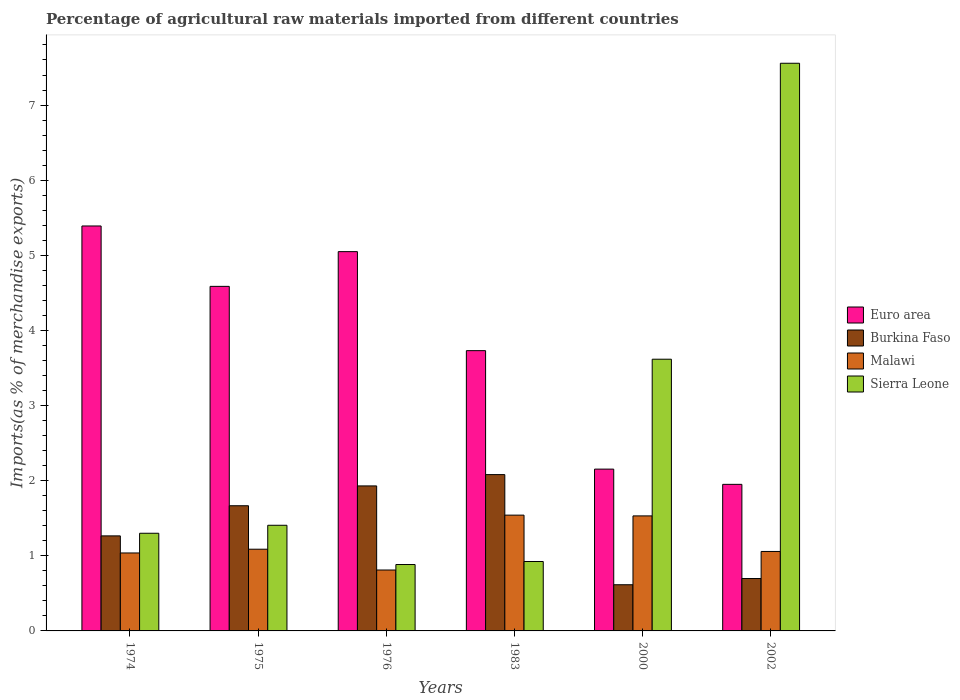Are the number of bars on each tick of the X-axis equal?
Provide a succinct answer. Yes. How many bars are there on the 4th tick from the right?
Provide a succinct answer. 4. What is the percentage of imports to different countries in Burkina Faso in 1983?
Ensure brevity in your answer.  2.08. Across all years, what is the maximum percentage of imports to different countries in Euro area?
Offer a terse response. 5.39. Across all years, what is the minimum percentage of imports to different countries in Burkina Faso?
Your response must be concise. 0.61. In which year was the percentage of imports to different countries in Sierra Leone maximum?
Make the answer very short. 2002. In which year was the percentage of imports to different countries in Euro area minimum?
Make the answer very short. 2002. What is the total percentage of imports to different countries in Sierra Leone in the graph?
Your answer should be compact. 15.69. What is the difference between the percentage of imports to different countries in Sierra Leone in 1974 and that in 2002?
Ensure brevity in your answer.  -6.26. What is the difference between the percentage of imports to different countries in Malawi in 1975 and the percentage of imports to different countries in Burkina Faso in 1974?
Ensure brevity in your answer.  -0.18. What is the average percentage of imports to different countries in Burkina Faso per year?
Provide a succinct answer. 1.38. In the year 1983, what is the difference between the percentage of imports to different countries in Burkina Faso and percentage of imports to different countries in Euro area?
Provide a short and direct response. -1.65. In how many years, is the percentage of imports to different countries in Sierra Leone greater than 6.4 %?
Provide a short and direct response. 1. What is the ratio of the percentage of imports to different countries in Malawi in 1974 to that in 1975?
Provide a succinct answer. 0.95. What is the difference between the highest and the second highest percentage of imports to different countries in Euro area?
Your answer should be compact. 0.34. What is the difference between the highest and the lowest percentage of imports to different countries in Sierra Leone?
Provide a short and direct response. 6.67. Is the sum of the percentage of imports to different countries in Burkina Faso in 1974 and 1976 greater than the maximum percentage of imports to different countries in Malawi across all years?
Your response must be concise. Yes. Is it the case that in every year, the sum of the percentage of imports to different countries in Malawi and percentage of imports to different countries in Burkina Faso is greater than the sum of percentage of imports to different countries in Sierra Leone and percentage of imports to different countries in Euro area?
Your answer should be very brief. No. What does the 4th bar from the left in 1976 represents?
Offer a very short reply. Sierra Leone. What does the 1st bar from the right in 1974 represents?
Your response must be concise. Sierra Leone. Is it the case that in every year, the sum of the percentage of imports to different countries in Sierra Leone and percentage of imports to different countries in Euro area is greater than the percentage of imports to different countries in Burkina Faso?
Keep it short and to the point. Yes. Are the values on the major ticks of Y-axis written in scientific E-notation?
Offer a very short reply. No. Does the graph contain any zero values?
Your response must be concise. No. Does the graph contain grids?
Your response must be concise. No. How many legend labels are there?
Offer a terse response. 4. What is the title of the graph?
Your answer should be very brief. Percentage of agricultural raw materials imported from different countries. What is the label or title of the X-axis?
Your answer should be compact. Years. What is the label or title of the Y-axis?
Ensure brevity in your answer.  Imports(as % of merchandise exports). What is the Imports(as % of merchandise exports) in Euro area in 1974?
Provide a short and direct response. 5.39. What is the Imports(as % of merchandise exports) of Burkina Faso in 1974?
Offer a terse response. 1.27. What is the Imports(as % of merchandise exports) in Malawi in 1974?
Provide a short and direct response. 1.04. What is the Imports(as % of merchandise exports) of Sierra Leone in 1974?
Keep it short and to the point. 1.3. What is the Imports(as % of merchandise exports) in Euro area in 1975?
Your response must be concise. 4.59. What is the Imports(as % of merchandise exports) in Burkina Faso in 1975?
Your answer should be compact. 1.67. What is the Imports(as % of merchandise exports) of Malawi in 1975?
Your answer should be compact. 1.09. What is the Imports(as % of merchandise exports) in Sierra Leone in 1975?
Give a very brief answer. 1.41. What is the Imports(as % of merchandise exports) of Euro area in 1976?
Ensure brevity in your answer.  5.05. What is the Imports(as % of merchandise exports) in Burkina Faso in 1976?
Provide a short and direct response. 1.93. What is the Imports(as % of merchandise exports) of Malawi in 1976?
Offer a terse response. 0.81. What is the Imports(as % of merchandise exports) in Sierra Leone in 1976?
Ensure brevity in your answer.  0.88. What is the Imports(as % of merchandise exports) of Euro area in 1983?
Your answer should be very brief. 3.73. What is the Imports(as % of merchandise exports) of Burkina Faso in 1983?
Your response must be concise. 2.08. What is the Imports(as % of merchandise exports) of Malawi in 1983?
Your answer should be very brief. 1.54. What is the Imports(as % of merchandise exports) of Sierra Leone in 1983?
Keep it short and to the point. 0.92. What is the Imports(as % of merchandise exports) in Euro area in 2000?
Keep it short and to the point. 2.15. What is the Imports(as % of merchandise exports) in Burkina Faso in 2000?
Ensure brevity in your answer.  0.61. What is the Imports(as % of merchandise exports) in Malawi in 2000?
Your answer should be very brief. 1.53. What is the Imports(as % of merchandise exports) of Sierra Leone in 2000?
Provide a succinct answer. 3.62. What is the Imports(as % of merchandise exports) in Euro area in 2002?
Provide a succinct answer. 1.95. What is the Imports(as % of merchandise exports) in Burkina Faso in 2002?
Provide a short and direct response. 0.7. What is the Imports(as % of merchandise exports) of Malawi in 2002?
Your answer should be very brief. 1.06. What is the Imports(as % of merchandise exports) of Sierra Leone in 2002?
Provide a short and direct response. 7.56. Across all years, what is the maximum Imports(as % of merchandise exports) of Euro area?
Ensure brevity in your answer.  5.39. Across all years, what is the maximum Imports(as % of merchandise exports) of Burkina Faso?
Your answer should be compact. 2.08. Across all years, what is the maximum Imports(as % of merchandise exports) in Malawi?
Provide a short and direct response. 1.54. Across all years, what is the maximum Imports(as % of merchandise exports) in Sierra Leone?
Offer a very short reply. 7.56. Across all years, what is the minimum Imports(as % of merchandise exports) in Euro area?
Keep it short and to the point. 1.95. Across all years, what is the minimum Imports(as % of merchandise exports) of Burkina Faso?
Offer a very short reply. 0.61. Across all years, what is the minimum Imports(as % of merchandise exports) of Malawi?
Offer a terse response. 0.81. Across all years, what is the minimum Imports(as % of merchandise exports) in Sierra Leone?
Your answer should be very brief. 0.88. What is the total Imports(as % of merchandise exports) in Euro area in the graph?
Your answer should be compact. 22.86. What is the total Imports(as % of merchandise exports) in Burkina Faso in the graph?
Your answer should be very brief. 8.25. What is the total Imports(as % of merchandise exports) in Malawi in the graph?
Offer a terse response. 7.07. What is the total Imports(as % of merchandise exports) of Sierra Leone in the graph?
Provide a short and direct response. 15.69. What is the difference between the Imports(as % of merchandise exports) in Euro area in 1974 and that in 1975?
Offer a terse response. 0.8. What is the difference between the Imports(as % of merchandise exports) in Burkina Faso in 1974 and that in 1975?
Provide a succinct answer. -0.4. What is the difference between the Imports(as % of merchandise exports) in Malawi in 1974 and that in 1975?
Keep it short and to the point. -0.05. What is the difference between the Imports(as % of merchandise exports) in Sierra Leone in 1974 and that in 1975?
Give a very brief answer. -0.11. What is the difference between the Imports(as % of merchandise exports) in Euro area in 1974 and that in 1976?
Make the answer very short. 0.34. What is the difference between the Imports(as % of merchandise exports) of Burkina Faso in 1974 and that in 1976?
Offer a terse response. -0.67. What is the difference between the Imports(as % of merchandise exports) in Malawi in 1974 and that in 1976?
Your answer should be very brief. 0.23. What is the difference between the Imports(as % of merchandise exports) of Sierra Leone in 1974 and that in 1976?
Your answer should be compact. 0.42. What is the difference between the Imports(as % of merchandise exports) in Euro area in 1974 and that in 1983?
Offer a very short reply. 1.66. What is the difference between the Imports(as % of merchandise exports) of Burkina Faso in 1974 and that in 1983?
Your answer should be compact. -0.82. What is the difference between the Imports(as % of merchandise exports) of Malawi in 1974 and that in 1983?
Give a very brief answer. -0.5. What is the difference between the Imports(as % of merchandise exports) of Sierra Leone in 1974 and that in 1983?
Keep it short and to the point. 0.38. What is the difference between the Imports(as % of merchandise exports) of Euro area in 1974 and that in 2000?
Ensure brevity in your answer.  3.24. What is the difference between the Imports(as % of merchandise exports) in Burkina Faso in 1974 and that in 2000?
Make the answer very short. 0.65. What is the difference between the Imports(as % of merchandise exports) in Malawi in 1974 and that in 2000?
Offer a terse response. -0.49. What is the difference between the Imports(as % of merchandise exports) of Sierra Leone in 1974 and that in 2000?
Keep it short and to the point. -2.32. What is the difference between the Imports(as % of merchandise exports) in Euro area in 1974 and that in 2002?
Ensure brevity in your answer.  3.44. What is the difference between the Imports(as % of merchandise exports) in Burkina Faso in 1974 and that in 2002?
Your answer should be very brief. 0.57. What is the difference between the Imports(as % of merchandise exports) of Malawi in 1974 and that in 2002?
Offer a very short reply. -0.02. What is the difference between the Imports(as % of merchandise exports) in Sierra Leone in 1974 and that in 2002?
Keep it short and to the point. -6.26. What is the difference between the Imports(as % of merchandise exports) in Euro area in 1975 and that in 1976?
Your answer should be compact. -0.46. What is the difference between the Imports(as % of merchandise exports) of Burkina Faso in 1975 and that in 1976?
Provide a short and direct response. -0.26. What is the difference between the Imports(as % of merchandise exports) in Malawi in 1975 and that in 1976?
Your response must be concise. 0.28. What is the difference between the Imports(as % of merchandise exports) of Sierra Leone in 1975 and that in 1976?
Your answer should be compact. 0.52. What is the difference between the Imports(as % of merchandise exports) of Euro area in 1975 and that in 1983?
Offer a terse response. 0.86. What is the difference between the Imports(as % of merchandise exports) in Burkina Faso in 1975 and that in 1983?
Provide a short and direct response. -0.41. What is the difference between the Imports(as % of merchandise exports) of Malawi in 1975 and that in 1983?
Offer a terse response. -0.45. What is the difference between the Imports(as % of merchandise exports) of Sierra Leone in 1975 and that in 1983?
Give a very brief answer. 0.48. What is the difference between the Imports(as % of merchandise exports) in Euro area in 1975 and that in 2000?
Offer a terse response. 2.43. What is the difference between the Imports(as % of merchandise exports) of Burkina Faso in 1975 and that in 2000?
Offer a terse response. 1.05. What is the difference between the Imports(as % of merchandise exports) of Malawi in 1975 and that in 2000?
Offer a terse response. -0.44. What is the difference between the Imports(as % of merchandise exports) in Sierra Leone in 1975 and that in 2000?
Keep it short and to the point. -2.21. What is the difference between the Imports(as % of merchandise exports) of Euro area in 1975 and that in 2002?
Ensure brevity in your answer.  2.64. What is the difference between the Imports(as % of merchandise exports) in Burkina Faso in 1975 and that in 2002?
Provide a succinct answer. 0.97. What is the difference between the Imports(as % of merchandise exports) of Malawi in 1975 and that in 2002?
Offer a very short reply. 0.03. What is the difference between the Imports(as % of merchandise exports) in Sierra Leone in 1975 and that in 2002?
Provide a short and direct response. -6.15. What is the difference between the Imports(as % of merchandise exports) of Euro area in 1976 and that in 1983?
Make the answer very short. 1.32. What is the difference between the Imports(as % of merchandise exports) in Burkina Faso in 1976 and that in 1983?
Provide a short and direct response. -0.15. What is the difference between the Imports(as % of merchandise exports) of Malawi in 1976 and that in 1983?
Keep it short and to the point. -0.73. What is the difference between the Imports(as % of merchandise exports) in Sierra Leone in 1976 and that in 1983?
Ensure brevity in your answer.  -0.04. What is the difference between the Imports(as % of merchandise exports) of Euro area in 1976 and that in 2000?
Give a very brief answer. 2.9. What is the difference between the Imports(as % of merchandise exports) in Burkina Faso in 1976 and that in 2000?
Your answer should be compact. 1.32. What is the difference between the Imports(as % of merchandise exports) in Malawi in 1976 and that in 2000?
Your answer should be very brief. -0.72. What is the difference between the Imports(as % of merchandise exports) in Sierra Leone in 1976 and that in 2000?
Provide a short and direct response. -2.73. What is the difference between the Imports(as % of merchandise exports) of Euro area in 1976 and that in 2002?
Your answer should be compact. 3.1. What is the difference between the Imports(as % of merchandise exports) in Burkina Faso in 1976 and that in 2002?
Offer a very short reply. 1.23. What is the difference between the Imports(as % of merchandise exports) of Malawi in 1976 and that in 2002?
Give a very brief answer. -0.25. What is the difference between the Imports(as % of merchandise exports) of Sierra Leone in 1976 and that in 2002?
Offer a very short reply. -6.67. What is the difference between the Imports(as % of merchandise exports) of Euro area in 1983 and that in 2000?
Provide a short and direct response. 1.58. What is the difference between the Imports(as % of merchandise exports) in Burkina Faso in 1983 and that in 2000?
Provide a succinct answer. 1.47. What is the difference between the Imports(as % of merchandise exports) of Malawi in 1983 and that in 2000?
Provide a succinct answer. 0.01. What is the difference between the Imports(as % of merchandise exports) in Sierra Leone in 1983 and that in 2000?
Make the answer very short. -2.69. What is the difference between the Imports(as % of merchandise exports) in Euro area in 1983 and that in 2002?
Offer a very short reply. 1.78. What is the difference between the Imports(as % of merchandise exports) in Burkina Faso in 1983 and that in 2002?
Provide a succinct answer. 1.38. What is the difference between the Imports(as % of merchandise exports) in Malawi in 1983 and that in 2002?
Give a very brief answer. 0.48. What is the difference between the Imports(as % of merchandise exports) in Sierra Leone in 1983 and that in 2002?
Your answer should be very brief. -6.63. What is the difference between the Imports(as % of merchandise exports) of Euro area in 2000 and that in 2002?
Offer a very short reply. 0.2. What is the difference between the Imports(as % of merchandise exports) in Burkina Faso in 2000 and that in 2002?
Your answer should be compact. -0.08. What is the difference between the Imports(as % of merchandise exports) in Malawi in 2000 and that in 2002?
Provide a short and direct response. 0.47. What is the difference between the Imports(as % of merchandise exports) in Sierra Leone in 2000 and that in 2002?
Offer a very short reply. -3.94. What is the difference between the Imports(as % of merchandise exports) of Euro area in 1974 and the Imports(as % of merchandise exports) of Burkina Faso in 1975?
Provide a short and direct response. 3.72. What is the difference between the Imports(as % of merchandise exports) of Euro area in 1974 and the Imports(as % of merchandise exports) of Malawi in 1975?
Offer a very short reply. 4.3. What is the difference between the Imports(as % of merchandise exports) of Euro area in 1974 and the Imports(as % of merchandise exports) of Sierra Leone in 1975?
Offer a very short reply. 3.98. What is the difference between the Imports(as % of merchandise exports) in Burkina Faso in 1974 and the Imports(as % of merchandise exports) in Malawi in 1975?
Your response must be concise. 0.18. What is the difference between the Imports(as % of merchandise exports) of Burkina Faso in 1974 and the Imports(as % of merchandise exports) of Sierra Leone in 1975?
Provide a succinct answer. -0.14. What is the difference between the Imports(as % of merchandise exports) of Malawi in 1974 and the Imports(as % of merchandise exports) of Sierra Leone in 1975?
Give a very brief answer. -0.37. What is the difference between the Imports(as % of merchandise exports) of Euro area in 1974 and the Imports(as % of merchandise exports) of Burkina Faso in 1976?
Provide a short and direct response. 3.46. What is the difference between the Imports(as % of merchandise exports) of Euro area in 1974 and the Imports(as % of merchandise exports) of Malawi in 1976?
Give a very brief answer. 4.58. What is the difference between the Imports(as % of merchandise exports) in Euro area in 1974 and the Imports(as % of merchandise exports) in Sierra Leone in 1976?
Your response must be concise. 4.51. What is the difference between the Imports(as % of merchandise exports) in Burkina Faso in 1974 and the Imports(as % of merchandise exports) in Malawi in 1976?
Your answer should be compact. 0.45. What is the difference between the Imports(as % of merchandise exports) of Burkina Faso in 1974 and the Imports(as % of merchandise exports) of Sierra Leone in 1976?
Provide a short and direct response. 0.38. What is the difference between the Imports(as % of merchandise exports) of Malawi in 1974 and the Imports(as % of merchandise exports) of Sierra Leone in 1976?
Keep it short and to the point. 0.15. What is the difference between the Imports(as % of merchandise exports) in Euro area in 1974 and the Imports(as % of merchandise exports) in Burkina Faso in 1983?
Offer a very short reply. 3.31. What is the difference between the Imports(as % of merchandise exports) of Euro area in 1974 and the Imports(as % of merchandise exports) of Malawi in 1983?
Your answer should be compact. 3.85. What is the difference between the Imports(as % of merchandise exports) in Euro area in 1974 and the Imports(as % of merchandise exports) in Sierra Leone in 1983?
Ensure brevity in your answer.  4.47. What is the difference between the Imports(as % of merchandise exports) in Burkina Faso in 1974 and the Imports(as % of merchandise exports) in Malawi in 1983?
Your response must be concise. -0.28. What is the difference between the Imports(as % of merchandise exports) of Burkina Faso in 1974 and the Imports(as % of merchandise exports) of Sierra Leone in 1983?
Your answer should be compact. 0.34. What is the difference between the Imports(as % of merchandise exports) in Malawi in 1974 and the Imports(as % of merchandise exports) in Sierra Leone in 1983?
Provide a short and direct response. 0.11. What is the difference between the Imports(as % of merchandise exports) of Euro area in 1974 and the Imports(as % of merchandise exports) of Burkina Faso in 2000?
Offer a very short reply. 4.78. What is the difference between the Imports(as % of merchandise exports) in Euro area in 1974 and the Imports(as % of merchandise exports) in Malawi in 2000?
Your response must be concise. 3.86. What is the difference between the Imports(as % of merchandise exports) in Euro area in 1974 and the Imports(as % of merchandise exports) in Sierra Leone in 2000?
Give a very brief answer. 1.77. What is the difference between the Imports(as % of merchandise exports) of Burkina Faso in 1974 and the Imports(as % of merchandise exports) of Malawi in 2000?
Provide a succinct answer. -0.27. What is the difference between the Imports(as % of merchandise exports) of Burkina Faso in 1974 and the Imports(as % of merchandise exports) of Sierra Leone in 2000?
Ensure brevity in your answer.  -2.35. What is the difference between the Imports(as % of merchandise exports) of Malawi in 1974 and the Imports(as % of merchandise exports) of Sierra Leone in 2000?
Give a very brief answer. -2.58. What is the difference between the Imports(as % of merchandise exports) in Euro area in 1974 and the Imports(as % of merchandise exports) in Burkina Faso in 2002?
Ensure brevity in your answer.  4.69. What is the difference between the Imports(as % of merchandise exports) in Euro area in 1974 and the Imports(as % of merchandise exports) in Malawi in 2002?
Offer a very short reply. 4.33. What is the difference between the Imports(as % of merchandise exports) of Euro area in 1974 and the Imports(as % of merchandise exports) of Sierra Leone in 2002?
Provide a short and direct response. -2.17. What is the difference between the Imports(as % of merchandise exports) of Burkina Faso in 1974 and the Imports(as % of merchandise exports) of Malawi in 2002?
Your answer should be very brief. 0.21. What is the difference between the Imports(as % of merchandise exports) in Burkina Faso in 1974 and the Imports(as % of merchandise exports) in Sierra Leone in 2002?
Your answer should be compact. -6.29. What is the difference between the Imports(as % of merchandise exports) in Malawi in 1974 and the Imports(as % of merchandise exports) in Sierra Leone in 2002?
Give a very brief answer. -6.52. What is the difference between the Imports(as % of merchandise exports) of Euro area in 1975 and the Imports(as % of merchandise exports) of Burkina Faso in 1976?
Provide a succinct answer. 2.66. What is the difference between the Imports(as % of merchandise exports) in Euro area in 1975 and the Imports(as % of merchandise exports) in Malawi in 1976?
Offer a terse response. 3.78. What is the difference between the Imports(as % of merchandise exports) in Euro area in 1975 and the Imports(as % of merchandise exports) in Sierra Leone in 1976?
Provide a short and direct response. 3.7. What is the difference between the Imports(as % of merchandise exports) in Burkina Faso in 1975 and the Imports(as % of merchandise exports) in Malawi in 1976?
Provide a succinct answer. 0.86. What is the difference between the Imports(as % of merchandise exports) in Burkina Faso in 1975 and the Imports(as % of merchandise exports) in Sierra Leone in 1976?
Your response must be concise. 0.78. What is the difference between the Imports(as % of merchandise exports) in Malawi in 1975 and the Imports(as % of merchandise exports) in Sierra Leone in 1976?
Offer a terse response. 0.2. What is the difference between the Imports(as % of merchandise exports) of Euro area in 1975 and the Imports(as % of merchandise exports) of Burkina Faso in 1983?
Offer a very short reply. 2.51. What is the difference between the Imports(as % of merchandise exports) of Euro area in 1975 and the Imports(as % of merchandise exports) of Malawi in 1983?
Keep it short and to the point. 3.05. What is the difference between the Imports(as % of merchandise exports) in Euro area in 1975 and the Imports(as % of merchandise exports) in Sierra Leone in 1983?
Give a very brief answer. 3.66. What is the difference between the Imports(as % of merchandise exports) in Burkina Faso in 1975 and the Imports(as % of merchandise exports) in Malawi in 1983?
Ensure brevity in your answer.  0.13. What is the difference between the Imports(as % of merchandise exports) in Burkina Faso in 1975 and the Imports(as % of merchandise exports) in Sierra Leone in 1983?
Keep it short and to the point. 0.74. What is the difference between the Imports(as % of merchandise exports) of Malawi in 1975 and the Imports(as % of merchandise exports) of Sierra Leone in 1983?
Your response must be concise. 0.16. What is the difference between the Imports(as % of merchandise exports) in Euro area in 1975 and the Imports(as % of merchandise exports) in Burkina Faso in 2000?
Keep it short and to the point. 3.97. What is the difference between the Imports(as % of merchandise exports) in Euro area in 1975 and the Imports(as % of merchandise exports) in Malawi in 2000?
Offer a very short reply. 3.06. What is the difference between the Imports(as % of merchandise exports) of Euro area in 1975 and the Imports(as % of merchandise exports) of Sierra Leone in 2000?
Your answer should be very brief. 0.97. What is the difference between the Imports(as % of merchandise exports) of Burkina Faso in 1975 and the Imports(as % of merchandise exports) of Malawi in 2000?
Make the answer very short. 0.14. What is the difference between the Imports(as % of merchandise exports) in Burkina Faso in 1975 and the Imports(as % of merchandise exports) in Sierra Leone in 2000?
Your response must be concise. -1.95. What is the difference between the Imports(as % of merchandise exports) of Malawi in 1975 and the Imports(as % of merchandise exports) of Sierra Leone in 2000?
Provide a short and direct response. -2.53. What is the difference between the Imports(as % of merchandise exports) of Euro area in 1975 and the Imports(as % of merchandise exports) of Burkina Faso in 2002?
Offer a terse response. 3.89. What is the difference between the Imports(as % of merchandise exports) of Euro area in 1975 and the Imports(as % of merchandise exports) of Malawi in 2002?
Make the answer very short. 3.53. What is the difference between the Imports(as % of merchandise exports) of Euro area in 1975 and the Imports(as % of merchandise exports) of Sierra Leone in 2002?
Provide a succinct answer. -2.97. What is the difference between the Imports(as % of merchandise exports) of Burkina Faso in 1975 and the Imports(as % of merchandise exports) of Malawi in 2002?
Provide a short and direct response. 0.61. What is the difference between the Imports(as % of merchandise exports) of Burkina Faso in 1975 and the Imports(as % of merchandise exports) of Sierra Leone in 2002?
Offer a terse response. -5.89. What is the difference between the Imports(as % of merchandise exports) of Malawi in 1975 and the Imports(as % of merchandise exports) of Sierra Leone in 2002?
Make the answer very short. -6.47. What is the difference between the Imports(as % of merchandise exports) in Euro area in 1976 and the Imports(as % of merchandise exports) in Burkina Faso in 1983?
Make the answer very short. 2.97. What is the difference between the Imports(as % of merchandise exports) of Euro area in 1976 and the Imports(as % of merchandise exports) of Malawi in 1983?
Ensure brevity in your answer.  3.51. What is the difference between the Imports(as % of merchandise exports) in Euro area in 1976 and the Imports(as % of merchandise exports) in Sierra Leone in 1983?
Your answer should be compact. 4.12. What is the difference between the Imports(as % of merchandise exports) in Burkina Faso in 1976 and the Imports(as % of merchandise exports) in Malawi in 1983?
Your answer should be compact. 0.39. What is the difference between the Imports(as % of merchandise exports) in Burkina Faso in 1976 and the Imports(as % of merchandise exports) in Sierra Leone in 1983?
Keep it short and to the point. 1.01. What is the difference between the Imports(as % of merchandise exports) in Malawi in 1976 and the Imports(as % of merchandise exports) in Sierra Leone in 1983?
Ensure brevity in your answer.  -0.11. What is the difference between the Imports(as % of merchandise exports) of Euro area in 1976 and the Imports(as % of merchandise exports) of Burkina Faso in 2000?
Ensure brevity in your answer.  4.43. What is the difference between the Imports(as % of merchandise exports) of Euro area in 1976 and the Imports(as % of merchandise exports) of Malawi in 2000?
Offer a terse response. 3.52. What is the difference between the Imports(as % of merchandise exports) of Euro area in 1976 and the Imports(as % of merchandise exports) of Sierra Leone in 2000?
Provide a succinct answer. 1.43. What is the difference between the Imports(as % of merchandise exports) in Burkina Faso in 1976 and the Imports(as % of merchandise exports) in Malawi in 2000?
Your answer should be very brief. 0.4. What is the difference between the Imports(as % of merchandise exports) of Burkina Faso in 1976 and the Imports(as % of merchandise exports) of Sierra Leone in 2000?
Provide a succinct answer. -1.69. What is the difference between the Imports(as % of merchandise exports) in Malawi in 1976 and the Imports(as % of merchandise exports) in Sierra Leone in 2000?
Your answer should be compact. -2.81. What is the difference between the Imports(as % of merchandise exports) in Euro area in 1976 and the Imports(as % of merchandise exports) in Burkina Faso in 2002?
Offer a very short reply. 4.35. What is the difference between the Imports(as % of merchandise exports) of Euro area in 1976 and the Imports(as % of merchandise exports) of Malawi in 2002?
Offer a very short reply. 3.99. What is the difference between the Imports(as % of merchandise exports) of Euro area in 1976 and the Imports(as % of merchandise exports) of Sierra Leone in 2002?
Offer a very short reply. -2.51. What is the difference between the Imports(as % of merchandise exports) of Burkina Faso in 1976 and the Imports(as % of merchandise exports) of Malawi in 2002?
Provide a short and direct response. 0.87. What is the difference between the Imports(as % of merchandise exports) of Burkina Faso in 1976 and the Imports(as % of merchandise exports) of Sierra Leone in 2002?
Give a very brief answer. -5.63. What is the difference between the Imports(as % of merchandise exports) of Malawi in 1976 and the Imports(as % of merchandise exports) of Sierra Leone in 2002?
Ensure brevity in your answer.  -6.75. What is the difference between the Imports(as % of merchandise exports) of Euro area in 1983 and the Imports(as % of merchandise exports) of Burkina Faso in 2000?
Offer a terse response. 3.12. What is the difference between the Imports(as % of merchandise exports) of Euro area in 1983 and the Imports(as % of merchandise exports) of Malawi in 2000?
Your answer should be compact. 2.2. What is the difference between the Imports(as % of merchandise exports) of Euro area in 1983 and the Imports(as % of merchandise exports) of Sierra Leone in 2000?
Keep it short and to the point. 0.11. What is the difference between the Imports(as % of merchandise exports) of Burkina Faso in 1983 and the Imports(as % of merchandise exports) of Malawi in 2000?
Give a very brief answer. 0.55. What is the difference between the Imports(as % of merchandise exports) of Burkina Faso in 1983 and the Imports(as % of merchandise exports) of Sierra Leone in 2000?
Provide a succinct answer. -1.54. What is the difference between the Imports(as % of merchandise exports) of Malawi in 1983 and the Imports(as % of merchandise exports) of Sierra Leone in 2000?
Provide a succinct answer. -2.08. What is the difference between the Imports(as % of merchandise exports) of Euro area in 1983 and the Imports(as % of merchandise exports) of Burkina Faso in 2002?
Your answer should be very brief. 3.03. What is the difference between the Imports(as % of merchandise exports) in Euro area in 1983 and the Imports(as % of merchandise exports) in Malawi in 2002?
Give a very brief answer. 2.67. What is the difference between the Imports(as % of merchandise exports) of Euro area in 1983 and the Imports(as % of merchandise exports) of Sierra Leone in 2002?
Offer a terse response. -3.83. What is the difference between the Imports(as % of merchandise exports) of Burkina Faso in 1983 and the Imports(as % of merchandise exports) of Malawi in 2002?
Your response must be concise. 1.02. What is the difference between the Imports(as % of merchandise exports) in Burkina Faso in 1983 and the Imports(as % of merchandise exports) in Sierra Leone in 2002?
Make the answer very short. -5.48. What is the difference between the Imports(as % of merchandise exports) in Malawi in 1983 and the Imports(as % of merchandise exports) in Sierra Leone in 2002?
Provide a short and direct response. -6.02. What is the difference between the Imports(as % of merchandise exports) of Euro area in 2000 and the Imports(as % of merchandise exports) of Burkina Faso in 2002?
Provide a succinct answer. 1.46. What is the difference between the Imports(as % of merchandise exports) in Euro area in 2000 and the Imports(as % of merchandise exports) in Malawi in 2002?
Offer a terse response. 1.1. What is the difference between the Imports(as % of merchandise exports) in Euro area in 2000 and the Imports(as % of merchandise exports) in Sierra Leone in 2002?
Make the answer very short. -5.4. What is the difference between the Imports(as % of merchandise exports) of Burkina Faso in 2000 and the Imports(as % of merchandise exports) of Malawi in 2002?
Make the answer very short. -0.44. What is the difference between the Imports(as % of merchandise exports) in Burkina Faso in 2000 and the Imports(as % of merchandise exports) in Sierra Leone in 2002?
Keep it short and to the point. -6.94. What is the difference between the Imports(as % of merchandise exports) in Malawi in 2000 and the Imports(as % of merchandise exports) in Sierra Leone in 2002?
Provide a short and direct response. -6.03. What is the average Imports(as % of merchandise exports) of Euro area per year?
Give a very brief answer. 3.81. What is the average Imports(as % of merchandise exports) in Burkina Faso per year?
Your response must be concise. 1.38. What is the average Imports(as % of merchandise exports) of Malawi per year?
Make the answer very short. 1.18. What is the average Imports(as % of merchandise exports) in Sierra Leone per year?
Make the answer very short. 2.61. In the year 1974, what is the difference between the Imports(as % of merchandise exports) of Euro area and Imports(as % of merchandise exports) of Burkina Faso?
Keep it short and to the point. 4.13. In the year 1974, what is the difference between the Imports(as % of merchandise exports) in Euro area and Imports(as % of merchandise exports) in Malawi?
Offer a very short reply. 4.35. In the year 1974, what is the difference between the Imports(as % of merchandise exports) in Euro area and Imports(as % of merchandise exports) in Sierra Leone?
Your response must be concise. 4.09. In the year 1974, what is the difference between the Imports(as % of merchandise exports) in Burkina Faso and Imports(as % of merchandise exports) in Malawi?
Make the answer very short. 0.23. In the year 1974, what is the difference between the Imports(as % of merchandise exports) in Burkina Faso and Imports(as % of merchandise exports) in Sierra Leone?
Your answer should be very brief. -0.03. In the year 1974, what is the difference between the Imports(as % of merchandise exports) of Malawi and Imports(as % of merchandise exports) of Sierra Leone?
Keep it short and to the point. -0.26. In the year 1975, what is the difference between the Imports(as % of merchandise exports) in Euro area and Imports(as % of merchandise exports) in Burkina Faso?
Give a very brief answer. 2.92. In the year 1975, what is the difference between the Imports(as % of merchandise exports) of Euro area and Imports(as % of merchandise exports) of Malawi?
Provide a succinct answer. 3.5. In the year 1975, what is the difference between the Imports(as % of merchandise exports) of Euro area and Imports(as % of merchandise exports) of Sierra Leone?
Provide a succinct answer. 3.18. In the year 1975, what is the difference between the Imports(as % of merchandise exports) in Burkina Faso and Imports(as % of merchandise exports) in Malawi?
Your answer should be compact. 0.58. In the year 1975, what is the difference between the Imports(as % of merchandise exports) of Burkina Faso and Imports(as % of merchandise exports) of Sierra Leone?
Provide a succinct answer. 0.26. In the year 1975, what is the difference between the Imports(as % of merchandise exports) in Malawi and Imports(as % of merchandise exports) in Sierra Leone?
Give a very brief answer. -0.32. In the year 1976, what is the difference between the Imports(as % of merchandise exports) of Euro area and Imports(as % of merchandise exports) of Burkina Faso?
Your answer should be very brief. 3.12. In the year 1976, what is the difference between the Imports(as % of merchandise exports) of Euro area and Imports(as % of merchandise exports) of Malawi?
Offer a terse response. 4.24. In the year 1976, what is the difference between the Imports(as % of merchandise exports) of Euro area and Imports(as % of merchandise exports) of Sierra Leone?
Keep it short and to the point. 4.17. In the year 1976, what is the difference between the Imports(as % of merchandise exports) in Burkina Faso and Imports(as % of merchandise exports) in Malawi?
Offer a terse response. 1.12. In the year 1976, what is the difference between the Imports(as % of merchandise exports) of Burkina Faso and Imports(as % of merchandise exports) of Sierra Leone?
Your answer should be compact. 1.05. In the year 1976, what is the difference between the Imports(as % of merchandise exports) in Malawi and Imports(as % of merchandise exports) in Sierra Leone?
Offer a terse response. -0.07. In the year 1983, what is the difference between the Imports(as % of merchandise exports) of Euro area and Imports(as % of merchandise exports) of Burkina Faso?
Provide a short and direct response. 1.65. In the year 1983, what is the difference between the Imports(as % of merchandise exports) in Euro area and Imports(as % of merchandise exports) in Malawi?
Keep it short and to the point. 2.19. In the year 1983, what is the difference between the Imports(as % of merchandise exports) of Euro area and Imports(as % of merchandise exports) of Sierra Leone?
Give a very brief answer. 2.81. In the year 1983, what is the difference between the Imports(as % of merchandise exports) of Burkina Faso and Imports(as % of merchandise exports) of Malawi?
Keep it short and to the point. 0.54. In the year 1983, what is the difference between the Imports(as % of merchandise exports) of Burkina Faso and Imports(as % of merchandise exports) of Sierra Leone?
Offer a very short reply. 1.16. In the year 1983, what is the difference between the Imports(as % of merchandise exports) of Malawi and Imports(as % of merchandise exports) of Sierra Leone?
Provide a succinct answer. 0.62. In the year 2000, what is the difference between the Imports(as % of merchandise exports) in Euro area and Imports(as % of merchandise exports) in Burkina Faso?
Your response must be concise. 1.54. In the year 2000, what is the difference between the Imports(as % of merchandise exports) of Euro area and Imports(as % of merchandise exports) of Malawi?
Keep it short and to the point. 0.62. In the year 2000, what is the difference between the Imports(as % of merchandise exports) in Euro area and Imports(as % of merchandise exports) in Sierra Leone?
Offer a very short reply. -1.46. In the year 2000, what is the difference between the Imports(as % of merchandise exports) of Burkina Faso and Imports(as % of merchandise exports) of Malawi?
Your answer should be very brief. -0.92. In the year 2000, what is the difference between the Imports(as % of merchandise exports) of Burkina Faso and Imports(as % of merchandise exports) of Sierra Leone?
Ensure brevity in your answer.  -3. In the year 2000, what is the difference between the Imports(as % of merchandise exports) of Malawi and Imports(as % of merchandise exports) of Sierra Leone?
Your answer should be compact. -2.09. In the year 2002, what is the difference between the Imports(as % of merchandise exports) in Euro area and Imports(as % of merchandise exports) in Burkina Faso?
Make the answer very short. 1.25. In the year 2002, what is the difference between the Imports(as % of merchandise exports) in Euro area and Imports(as % of merchandise exports) in Malawi?
Make the answer very short. 0.89. In the year 2002, what is the difference between the Imports(as % of merchandise exports) in Euro area and Imports(as % of merchandise exports) in Sierra Leone?
Your answer should be compact. -5.61. In the year 2002, what is the difference between the Imports(as % of merchandise exports) of Burkina Faso and Imports(as % of merchandise exports) of Malawi?
Give a very brief answer. -0.36. In the year 2002, what is the difference between the Imports(as % of merchandise exports) of Burkina Faso and Imports(as % of merchandise exports) of Sierra Leone?
Your answer should be very brief. -6.86. In the year 2002, what is the difference between the Imports(as % of merchandise exports) of Malawi and Imports(as % of merchandise exports) of Sierra Leone?
Your answer should be compact. -6.5. What is the ratio of the Imports(as % of merchandise exports) in Euro area in 1974 to that in 1975?
Provide a short and direct response. 1.18. What is the ratio of the Imports(as % of merchandise exports) in Burkina Faso in 1974 to that in 1975?
Offer a terse response. 0.76. What is the ratio of the Imports(as % of merchandise exports) of Malawi in 1974 to that in 1975?
Your answer should be compact. 0.95. What is the ratio of the Imports(as % of merchandise exports) of Sierra Leone in 1974 to that in 1975?
Keep it short and to the point. 0.92. What is the ratio of the Imports(as % of merchandise exports) of Euro area in 1974 to that in 1976?
Offer a terse response. 1.07. What is the ratio of the Imports(as % of merchandise exports) in Burkina Faso in 1974 to that in 1976?
Your answer should be very brief. 0.66. What is the ratio of the Imports(as % of merchandise exports) of Malawi in 1974 to that in 1976?
Make the answer very short. 1.28. What is the ratio of the Imports(as % of merchandise exports) in Sierra Leone in 1974 to that in 1976?
Offer a terse response. 1.47. What is the ratio of the Imports(as % of merchandise exports) of Euro area in 1974 to that in 1983?
Make the answer very short. 1.44. What is the ratio of the Imports(as % of merchandise exports) of Burkina Faso in 1974 to that in 1983?
Keep it short and to the point. 0.61. What is the ratio of the Imports(as % of merchandise exports) of Malawi in 1974 to that in 1983?
Provide a short and direct response. 0.67. What is the ratio of the Imports(as % of merchandise exports) in Sierra Leone in 1974 to that in 1983?
Give a very brief answer. 1.41. What is the ratio of the Imports(as % of merchandise exports) in Euro area in 1974 to that in 2000?
Make the answer very short. 2.5. What is the ratio of the Imports(as % of merchandise exports) of Burkina Faso in 1974 to that in 2000?
Give a very brief answer. 2.06. What is the ratio of the Imports(as % of merchandise exports) of Malawi in 1974 to that in 2000?
Your answer should be compact. 0.68. What is the ratio of the Imports(as % of merchandise exports) in Sierra Leone in 1974 to that in 2000?
Keep it short and to the point. 0.36. What is the ratio of the Imports(as % of merchandise exports) in Euro area in 1974 to that in 2002?
Offer a very short reply. 2.76. What is the ratio of the Imports(as % of merchandise exports) in Burkina Faso in 1974 to that in 2002?
Offer a terse response. 1.81. What is the ratio of the Imports(as % of merchandise exports) in Sierra Leone in 1974 to that in 2002?
Provide a short and direct response. 0.17. What is the ratio of the Imports(as % of merchandise exports) of Euro area in 1975 to that in 1976?
Provide a short and direct response. 0.91. What is the ratio of the Imports(as % of merchandise exports) of Burkina Faso in 1975 to that in 1976?
Provide a succinct answer. 0.86. What is the ratio of the Imports(as % of merchandise exports) of Malawi in 1975 to that in 1976?
Offer a terse response. 1.34. What is the ratio of the Imports(as % of merchandise exports) of Sierra Leone in 1975 to that in 1976?
Your answer should be compact. 1.59. What is the ratio of the Imports(as % of merchandise exports) in Euro area in 1975 to that in 1983?
Provide a short and direct response. 1.23. What is the ratio of the Imports(as % of merchandise exports) in Burkina Faso in 1975 to that in 1983?
Provide a succinct answer. 0.8. What is the ratio of the Imports(as % of merchandise exports) of Malawi in 1975 to that in 1983?
Your answer should be very brief. 0.71. What is the ratio of the Imports(as % of merchandise exports) of Sierra Leone in 1975 to that in 1983?
Your response must be concise. 1.52. What is the ratio of the Imports(as % of merchandise exports) in Euro area in 1975 to that in 2000?
Provide a succinct answer. 2.13. What is the ratio of the Imports(as % of merchandise exports) in Burkina Faso in 1975 to that in 2000?
Your response must be concise. 2.71. What is the ratio of the Imports(as % of merchandise exports) of Malawi in 1975 to that in 2000?
Give a very brief answer. 0.71. What is the ratio of the Imports(as % of merchandise exports) in Sierra Leone in 1975 to that in 2000?
Your answer should be compact. 0.39. What is the ratio of the Imports(as % of merchandise exports) in Euro area in 1975 to that in 2002?
Your answer should be very brief. 2.35. What is the ratio of the Imports(as % of merchandise exports) of Burkina Faso in 1975 to that in 2002?
Your answer should be very brief. 2.39. What is the ratio of the Imports(as % of merchandise exports) in Malawi in 1975 to that in 2002?
Offer a terse response. 1.03. What is the ratio of the Imports(as % of merchandise exports) of Sierra Leone in 1975 to that in 2002?
Provide a short and direct response. 0.19. What is the ratio of the Imports(as % of merchandise exports) of Euro area in 1976 to that in 1983?
Keep it short and to the point. 1.35. What is the ratio of the Imports(as % of merchandise exports) in Burkina Faso in 1976 to that in 1983?
Offer a terse response. 0.93. What is the ratio of the Imports(as % of merchandise exports) in Malawi in 1976 to that in 1983?
Provide a short and direct response. 0.53. What is the ratio of the Imports(as % of merchandise exports) of Sierra Leone in 1976 to that in 1983?
Keep it short and to the point. 0.96. What is the ratio of the Imports(as % of merchandise exports) of Euro area in 1976 to that in 2000?
Keep it short and to the point. 2.34. What is the ratio of the Imports(as % of merchandise exports) of Burkina Faso in 1976 to that in 2000?
Keep it short and to the point. 3.14. What is the ratio of the Imports(as % of merchandise exports) in Malawi in 1976 to that in 2000?
Make the answer very short. 0.53. What is the ratio of the Imports(as % of merchandise exports) in Sierra Leone in 1976 to that in 2000?
Offer a terse response. 0.24. What is the ratio of the Imports(as % of merchandise exports) of Euro area in 1976 to that in 2002?
Keep it short and to the point. 2.59. What is the ratio of the Imports(as % of merchandise exports) in Burkina Faso in 1976 to that in 2002?
Offer a terse response. 2.77. What is the ratio of the Imports(as % of merchandise exports) in Malawi in 1976 to that in 2002?
Offer a very short reply. 0.77. What is the ratio of the Imports(as % of merchandise exports) of Sierra Leone in 1976 to that in 2002?
Your response must be concise. 0.12. What is the ratio of the Imports(as % of merchandise exports) in Euro area in 1983 to that in 2000?
Ensure brevity in your answer.  1.73. What is the ratio of the Imports(as % of merchandise exports) in Burkina Faso in 1983 to that in 2000?
Give a very brief answer. 3.39. What is the ratio of the Imports(as % of merchandise exports) of Malawi in 1983 to that in 2000?
Provide a short and direct response. 1.01. What is the ratio of the Imports(as % of merchandise exports) of Sierra Leone in 1983 to that in 2000?
Offer a terse response. 0.26. What is the ratio of the Imports(as % of merchandise exports) of Euro area in 1983 to that in 2002?
Offer a very short reply. 1.91. What is the ratio of the Imports(as % of merchandise exports) in Burkina Faso in 1983 to that in 2002?
Offer a very short reply. 2.98. What is the ratio of the Imports(as % of merchandise exports) of Malawi in 1983 to that in 2002?
Make the answer very short. 1.46. What is the ratio of the Imports(as % of merchandise exports) in Sierra Leone in 1983 to that in 2002?
Keep it short and to the point. 0.12. What is the ratio of the Imports(as % of merchandise exports) in Euro area in 2000 to that in 2002?
Provide a short and direct response. 1.1. What is the ratio of the Imports(as % of merchandise exports) of Burkina Faso in 2000 to that in 2002?
Your answer should be compact. 0.88. What is the ratio of the Imports(as % of merchandise exports) of Malawi in 2000 to that in 2002?
Ensure brevity in your answer.  1.45. What is the ratio of the Imports(as % of merchandise exports) of Sierra Leone in 2000 to that in 2002?
Provide a succinct answer. 0.48. What is the difference between the highest and the second highest Imports(as % of merchandise exports) of Euro area?
Provide a succinct answer. 0.34. What is the difference between the highest and the second highest Imports(as % of merchandise exports) of Burkina Faso?
Your answer should be compact. 0.15. What is the difference between the highest and the second highest Imports(as % of merchandise exports) in Malawi?
Give a very brief answer. 0.01. What is the difference between the highest and the second highest Imports(as % of merchandise exports) in Sierra Leone?
Offer a terse response. 3.94. What is the difference between the highest and the lowest Imports(as % of merchandise exports) of Euro area?
Keep it short and to the point. 3.44. What is the difference between the highest and the lowest Imports(as % of merchandise exports) of Burkina Faso?
Provide a short and direct response. 1.47. What is the difference between the highest and the lowest Imports(as % of merchandise exports) in Malawi?
Provide a succinct answer. 0.73. What is the difference between the highest and the lowest Imports(as % of merchandise exports) of Sierra Leone?
Offer a very short reply. 6.67. 